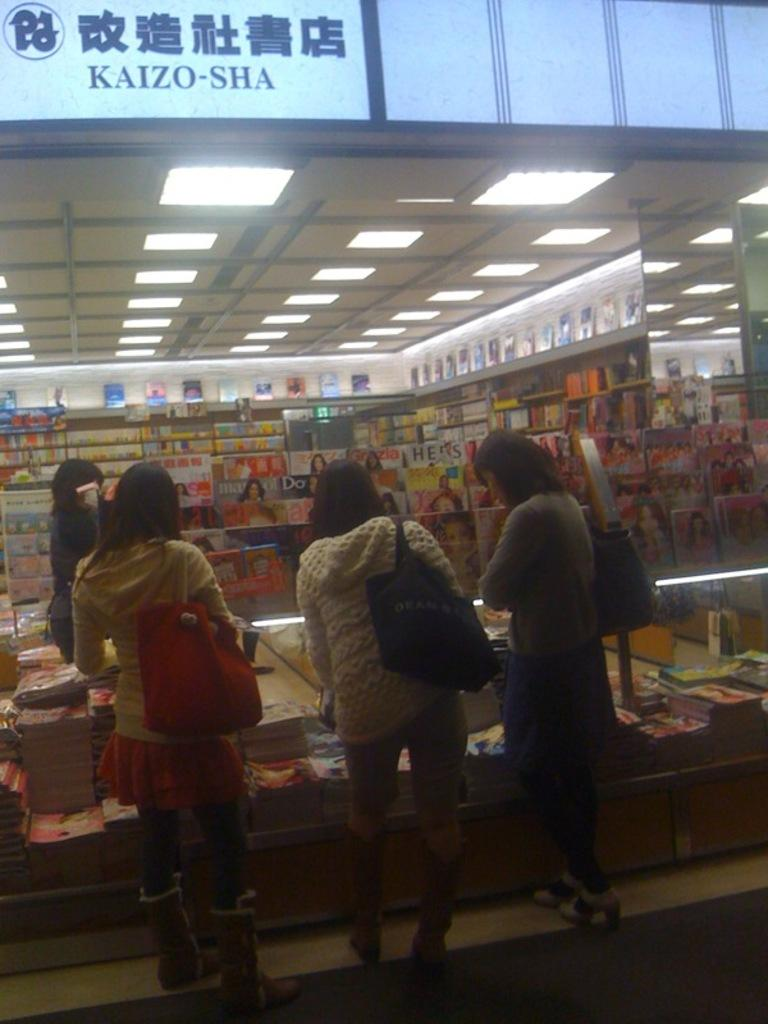<image>
Offer a succinct explanation of the picture presented. The sign with the name Kaizo-Sha written on it. 